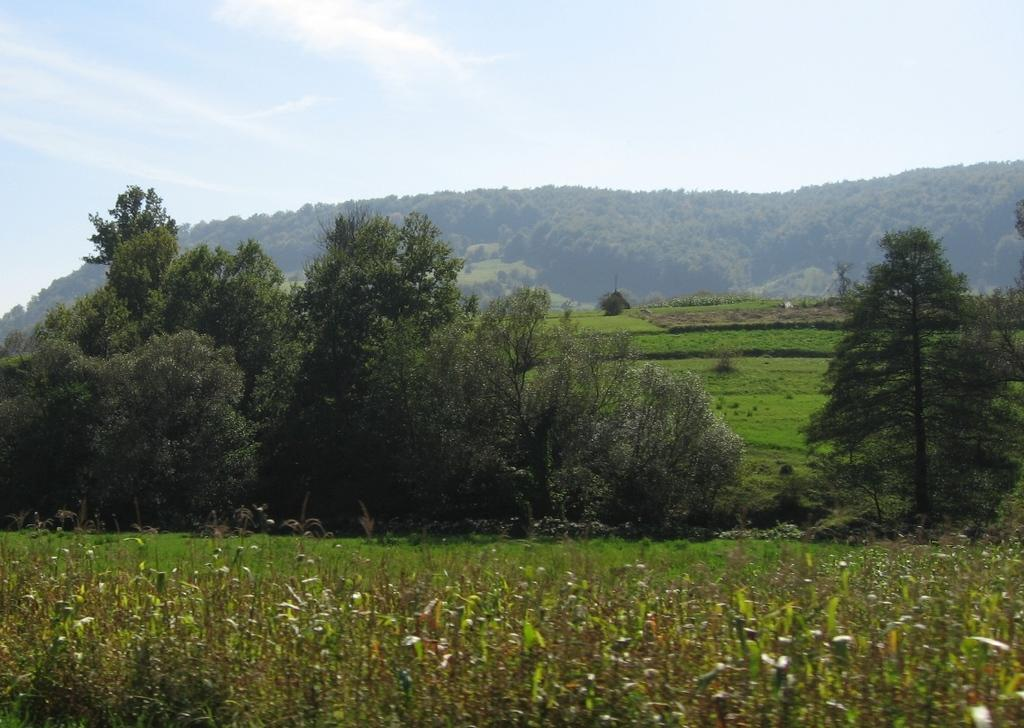What type of vegetation is present in the image? There are plants, trees, and grass in the image. What type of landscape feature can be seen in the image? There are hills in the image. What part of the natural environment is visible in the image? The sky is visible in the image. What type of dolls are present in the image? There are no dolls present in the image. What is your opinion on the suit worn by the person in the image? There is no person wearing a suit in the image, as it features plants, trees, grass, hills, and the sky. 